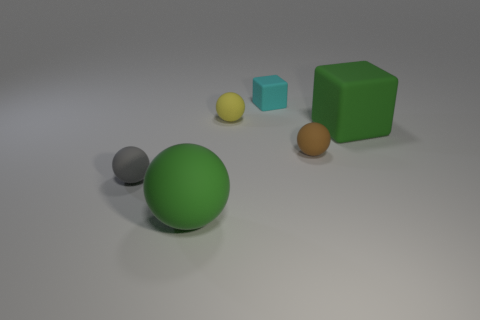Is the tiny gray thing that is in front of the small yellow rubber thing made of the same material as the big green object that is to the right of the big sphere?
Your response must be concise. Yes. There is a cyan block that is the same material as the gray ball; what size is it?
Offer a very short reply. Small. There is a large object right of the yellow sphere; what is its shape?
Your answer should be compact. Cube. There is a matte block in front of the cyan matte block; is its color the same as the matte object in front of the small gray matte sphere?
Offer a terse response. Yes. What size is the rubber thing that is the same color as the large block?
Your answer should be very brief. Large. Is there a big cube?
Your answer should be compact. Yes. What shape is the rubber thing that is behind the small matte sphere that is behind the green object to the right of the small brown ball?
Keep it short and to the point. Cube. There is a large green matte block; how many tiny brown rubber objects are behind it?
Offer a very short reply. 0. Is the big object that is left of the tiny brown rubber object made of the same material as the yellow ball?
Provide a succinct answer. Yes. How many other things are the same shape as the yellow object?
Make the answer very short. 3. 